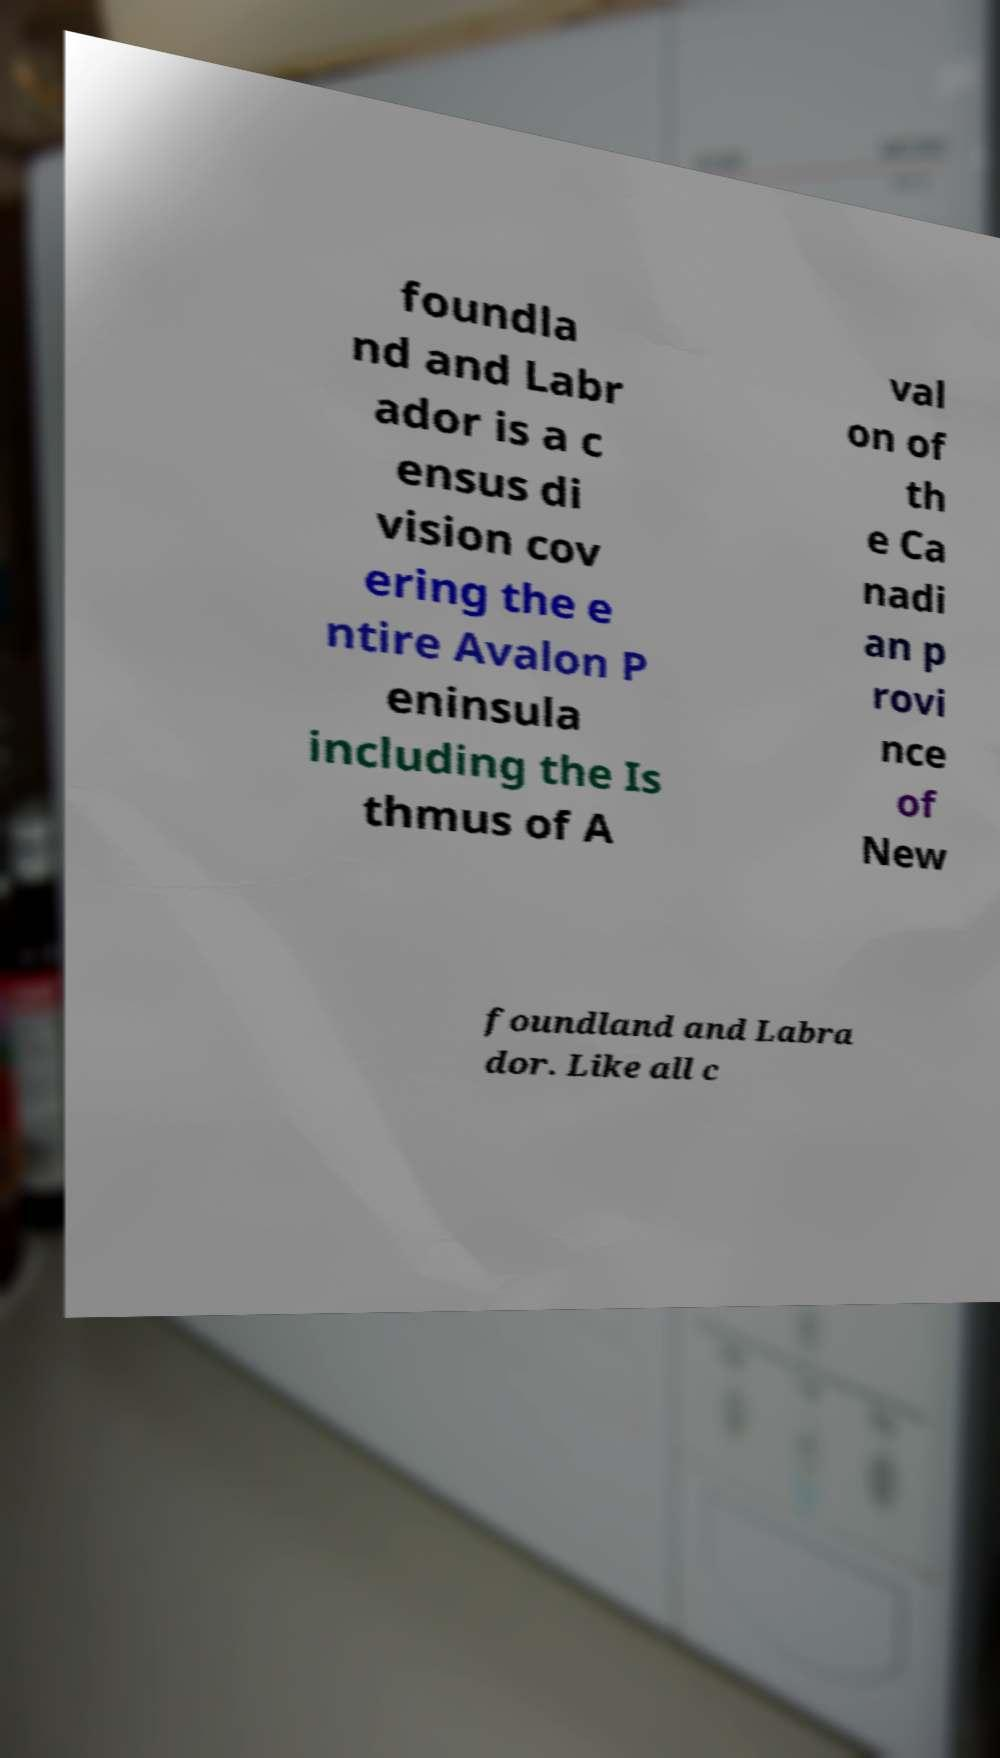There's text embedded in this image that I need extracted. Can you transcribe it verbatim? foundla nd and Labr ador is a c ensus di vision cov ering the e ntire Avalon P eninsula including the Is thmus of A val on of th e Ca nadi an p rovi nce of New foundland and Labra dor. Like all c 